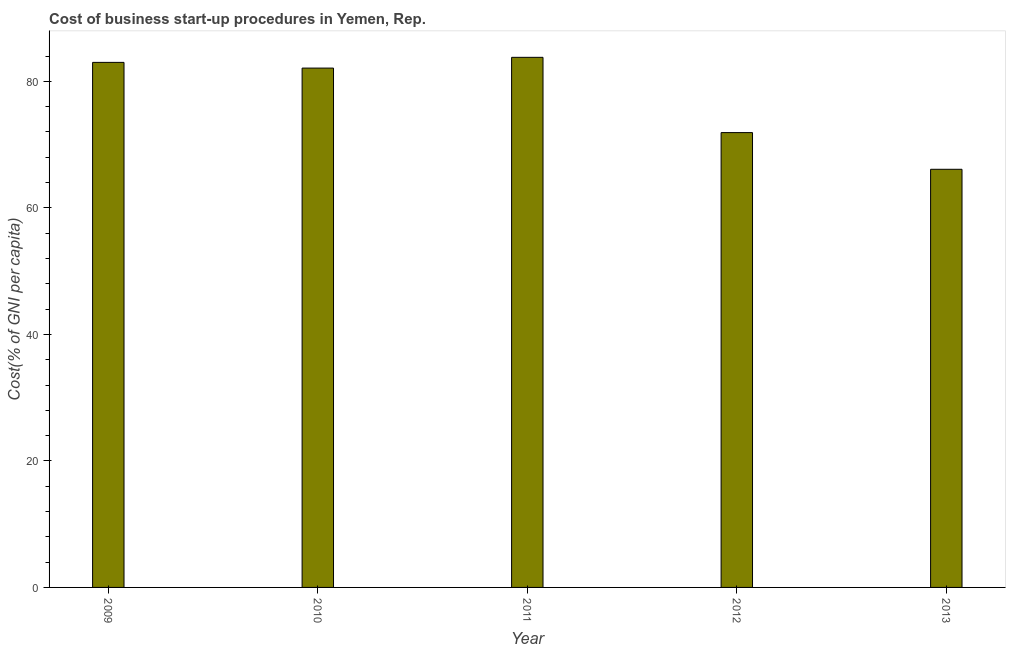Does the graph contain any zero values?
Offer a very short reply. No. What is the title of the graph?
Provide a succinct answer. Cost of business start-up procedures in Yemen, Rep. What is the label or title of the X-axis?
Offer a very short reply. Year. What is the label or title of the Y-axis?
Offer a terse response. Cost(% of GNI per capita). What is the cost of business startup procedures in 2012?
Keep it short and to the point. 71.9. Across all years, what is the maximum cost of business startup procedures?
Give a very brief answer. 83.8. Across all years, what is the minimum cost of business startup procedures?
Offer a very short reply. 66.1. What is the sum of the cost of business startup procedures?
Keep it short and to the point. 386.9. What is the average cost of business startup procedures per year?
Make the answer very short. 77.38. What is the median cost of business startup procedures?
Provide a short and direct response. 82.1. Do a majority of the years between 2009 and 2011 (inclusive) have cost of business startup procedures greater than 48 %?
Your answer should be compact. Yes. What is the ratio of the cost of business startup procedures in 2011 to that in 2012?
Offer a very short reply. 1.17. Is the cost of business startup procedures in 2009 less than that in 2011?
Give a very brief answer. Yes. Is the difference between the cost of business startup procedures in 2010 and 2013 greater than the difference between any two years?
Provide a succinct answer. No. What is the difference between the highest and the second highest cost of business startup procedures?
Offer a very short reply. 0.8. What is the difference between the highest and the lowest cost of business startup procedures?
Your answer should be compact. 17.7. In how many years, is the cost of business startup procedures greater than the average cost of business startup procedures taken over all years?
Your answer should be compact. 3. How many bars are there?
Give a very brief answer. 5. How many years are there in the graph?
Make the answer very short. 5. What is the difference between two consecutive major ticks on the Y-axis?
Your answer should be very brief. 20. What is the Cost(% of GNI per capita) of 2010?
Offer a very short reply. 82.1. What is the Cost(% of GNI per capita) in 2011?
Your response must be concise. 83.8. What is the Cost(% of GNI per capita) of 2012?
Your answer should be compact. 71.9. What is the Cost(% of GNI per capita) of 2013?
Your response must be concise. 66.1. What is the difference between the Cost(% of GNI per capita) in 2009 and 2011?
Give a very brief answer. -0.8. What is the difference between the Cost(% of GNI per capita) in 2010 and 2011?
Provide a short and direct response. -1.7. What is the difference between the Cost(% of GNI per capita) in 2010 and 2012?
Provide a succinct answer. 10.2. What is the difference between the Cost(% of GNI per capita) in 2011 and 2012?
Provide a short and direct response. 11.9. What is the difference between the Cost(% of GNI per capita) in 2011 and 2013?
Give a very brief answer. 17.7. What is the difference between the Cost(% of GNI per capita) in 2012 and 2013?
Your answer should be compact. 5.8. What is the ratio of the Cost(% of GNI per capita) in 2009 to that in 2010?
Offer a terse response. 1.01. What is the ratio of the Cost(% of GNI per capita) in 2009 to that in 2011?
Provide a short and direct response. 0.99. What is the ratio of the Cost(% of GNI per capita) in 2009 to that in 2012?
Provide a short and direct response. 1.15. What is the ratio of the Cost(% of GNI per capita) in 2009 to that in 2013?
Ensure brevity in your answer.  1.26. What is the ratio of the Cost(% of GNI per capita) in 2010 to that in 2012?
Make the answer very short. 1.14. What is the ratio of the Cost(% of GNI per capita) in 2010 to that in 2013?
Offer a very short reply. 1.24. What is the ratio of the Cost(% of GNI per capita) in 2011 to that in 2012?
Make the answer very short. 1.17. What is the ratio of the Cost(% of GNI per capita) in 2011 to that in 2013?
Offer a very short reply. 1.27. What is the ratio of the Cost(% of GNI per capita) in 2012 to that in 2013?
Make the answer very short. 1.09. 